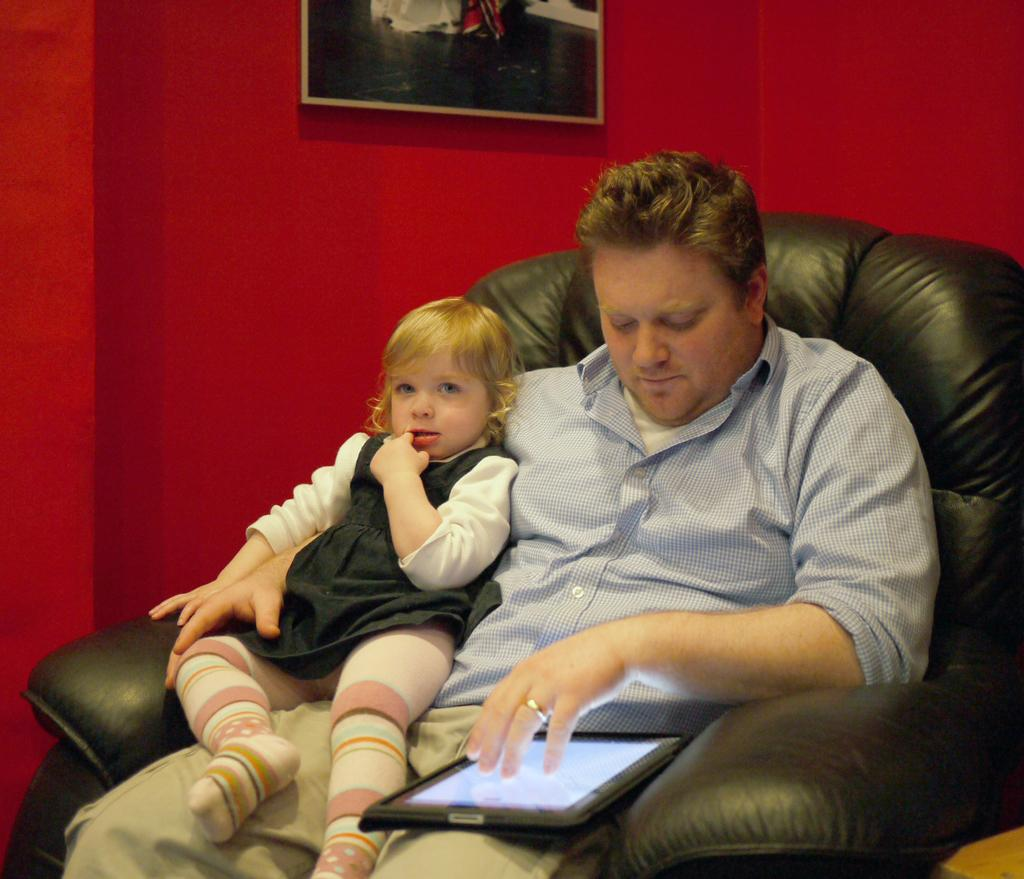Who is present in the image? There is a person and a kid in the image. What are they doing in the image? The person and kid are sitting on a chair and using a tablet. What can be seen in the background of the image? There is a wall in the background of the image. Is there anything hanging on the wall? Yes, there is a photo frame on the wall. What type of amusement park can be seen in the background of the image? There is no amusement park present in the image; it features a person and a kid sitting on a chair and using a tablet. What color is the chain that the kid is holding in the image? There is no chain present in the image; the kid is using a tablet with the person. 